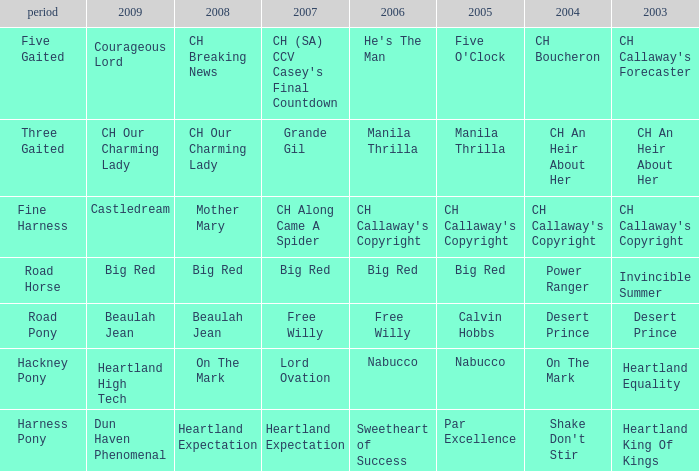What information is in the 2007 release featuring ch callaway's copyright from 2003? CH Along Came A Spider. 